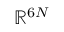Convert formula to latex. <formula><loc_0><loc_0><loc_500><loc_500>\mathbb { R } ^ { 6 N }</formula> 